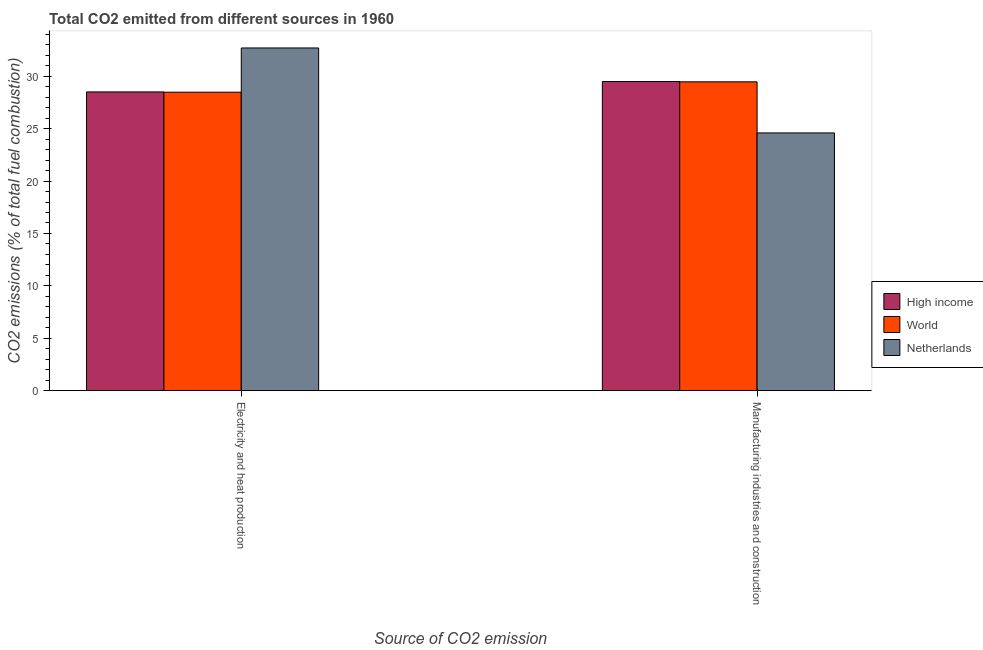How many different coloured bars are there?
Keep it short and to the point. 3. How many bars are there on the 2nd tick from the right?
Make the answer very short. 3. What is the label of the 2nd group of bars from the left?
Your answer should be very brief. Manufacturing industries and construction. What is the co2 emissions due to electricity and heat production in Netherlands?
Provide a succinct answer. 32.7. Across all countries, what is the maximum co2 emissions due to manufacturing industries?
Your answer should be very brief. 29.5. Across all countries, what is the minimum co2 emissions due to manufacturing industries?
Make the answer very short. 24.59. In which country was the co2 emissions due to electricity and heat production minimum?
Provide a succinct answer. World. What is the total co2 emissions due to electricity and heat production in the graph?
Ensure brevity in your answer.  89.69. What is the difference between the co2 emissions due to electricity and heat production in High income and that in Netherlands?
Make the answer very short. -4.19. What is the difference between the co2 emissions due to electricity and heat production in World and the co2 emissions due to manufacturing industries in High income?
Offer a very short reply. -1.02. What is the average co2 emissions due to electricity and heat production per country?
Offer a very short reply. 29.9. What is the difference between the co2 emissions due to electricity and heat production and co2 emissions due to manufacturing industries in Netherlands?
Provide a short and direct response. 8.11. In how many countries, is the co2 emissions due to manufacturing industries greater than 20 %?
Offer a terse response. 3. What is the ratio of the co2 emissions due to electricity and heat production in World to that in Netherlands?
Your answer should be very brief. 0.87. Is the co2 emissions due to manufacturing industries in Netherlands less than that in High income?
Your answer should be very brief. Yes. In how many countries, is the co2 emissions due to electricity and heat production greater than the average co2 emissions due to electricity and heat production taken over all countries?
Your response must be concise. 1. How many bars are there?
Ensure brevity in your answer.  6. How many countries are there in the graph?
Make the answer very short. 3. What is the difference between two consecutive major ticks on the Y-axis?
Your answer should be very brief. 5. Are the values on the major ticks of Y-axis written in scientific E-notation?
Provide a short and direct response. No. Does the graph contain grids?
Give a very brief answer. No. How many legend labels are there?
Make the answer very short. 3. How are the legend labels stacked?
Give a very brief answer. Vertical. What is the title of the graph?
Your response must be concise. Total CO2 emitted from different sources in 1960. What is the label or title of the X-axis?
Make the answer very short. Source of CO2 emission. What is the label or title of the Y-axis?
Your answer should be compact. CO2 emissions (% of total fuel combustion). What is the CO2 emissions (% of total fuel combustion) of High income in Electricity and heat production?
Provide a succinct answer. 28.51. What is the CO2 emissions (% of total fuel combustion) in World in Electricity and heat production?
Your answer should be compact. 28.48. What is the CO2 emissions (% of total fuel combustion) in Netherlands in Electricity and heat production?
Your answer should be very brief. 32.7. What is the CO2 emissions (% of total fuel combustion) of High income in Manufacturing industries and construction?
Provide a succinct answer. 29.5. What is the CO2 emissions (% of total fuel combustion) of World in Manufacturing industries and construction?
Your answer should be compact. 29.47. What is the CO2 emissions (% of total fuel combustion) of Netherlands in Manufacturing industries and construction?
Give a very brief answer. 24.59. Across all Source of CO2 emission, what is the maximum CO2 emissions (% of total fuel combustion) of High income?
Your response must be concise. 29.5. Across all Source of CO2 emission, what is the maximum CO2 emissions (% of total fuel combustion) in World?
Offer a terse response. 29.47. Across all Source of CO2 emission, what is the maximum CO2 emissions (% of total fuel combustion) in Netherlands?
Offer a terse response. 32.7. Across all Source of CO2 emission, what is the minimum CO2 emissions (% of total fuel combustion) in High income?
Make the answer very short. 28.51. Across all Source of CO2 emission, what is the minimum CO2 emissions (% of total fuel combustion) of World?
Your response must be concise. 28.48. Across all Source of CO2 emission, what is the minimum CO2 emissions (% of total fuel combustion) of Netherlands?
Offer a very short reply. 24.59. What is the total CO2 emissions (% of total fuel combustion) in High income in the graph?
Offer a terse response. 58. What is the total CO2 emissions (% of total fuel combustion) of World in the graph?
Your answer should be compact. 57.95. What is the total CO2 emissions (% of total fuel combustion) in Netherlands in the graph?
Make the answer very short. 57.29. What is the difference between the CO2 emissions (% of total fuel combustion) of High income in Electricity and heat production and that in Manufacturing industries and construction?
Your answer should be very brief. -0.99. What is the difference between the CO2 emissions (% of total fuel combustion) in World in Electricity and heat production and that in Manufacturing industries and construction?
Make the answer very short. -0.99. What is the difference between the CO2 emissions (% of total fuel combustion) of Netherlands in Electricity and heat production and that in Manufacturing industries and construction?
Ensure brevity in your answer.  8.11. What is the difference between the CO2 emissions (% of total fuel combustion) in High income in Electricity and heat production and the CO2 emissions (% of total fuel combustion) in World in Manufacturing industries and construction?
Your response must be concise. -0.96. What is the difference between the CO2 emissions (% of total fuel combustion) of High income in Electricity and heat production and the CO2 emissions (% of total fuel combustion) of Netherlands in Manufacturing industries and construction?
Ensure brevity in your answer.  3.91. What is the difference between the CO2 emissions (% of total fuel combustion) of World in Electricity and heat production and the CO2 emissions (% of total fuel combustion) of Netherlands in Manufacturing industries and construction?
Offer a very short reply. 3.89. What is the average CO2 emissions (% of total fuel combustion) in High income per Source of CO2 emission?
Offer a terse response. 29. What is the average CO2 emissions (% of total fuel combustion) in World per Source of CO2 emission?
Keep it short and to the point. 28.97. What is the average CO2 emissions (% of total fuel combustion) of Netherlands per Source of CO2 emission?
Provide a short and direct response. 28.65. What is the difference between the CO2 emissions (% of total fuel combustion) of High income and CO2 emissions (% of total fuel combustion) of World in Electricity and heat production?
Your answer should be very brief. 0.03. What is the difference between the CO2 emissions (% of total fuel combustion) in High income and CO2 emissions (% of total fuel combustion) in Netherlands in Electricity and heat production?
Provide a short and direct response. -4.19. What is the difference between the CO2 emissions (% of total fuel combustion) of World and CO2 emissions (% of total fuel combustion) of Netherlands in Electricity and heat production?
Your answer should be very brief. -4.22. What is the difference between the CO2 emissions (% of total fuel combustion) of High income and CO2 emissions (% of total fuel combustion) of World in Manufacturing industries and construction?
Provide a succinct answer. 0.03. What is the difference between the CO2 emissions (% of total fuel combustion) of High income and CO2 emissions (% of total fuel combustion) of Netherlands in Manufacturing industries and construction?
Offer a very short reply. 4.9. What is the difference between the CO2 emissions (% of total fuel combustion) of World and CO2 emissions (% of total fuel combustion) of Netherlands in Manufacturing industries and construction?
Offer a very short reply. 4.87. What is the ratio of the CO2 emissions (% of total fuel combustion) of High income in Electricity and heat production to that in Manufacturing industries and construction?
Your answer should be compact. 0.97. What is the ratio of the CO2 emissions (% of total fuel combustion) of World in Electricity and heat production to that in Manufacturing industries and construction?
Offer a very short reply. 0.97. What is the ratio of the CO2 emissions (% of total fuel combustion) in Netherlands in Electricity and heat production to that in Manufacturing industries and construction?
Ensure brevity in your answer.  1.33. What is the difference between the highest and the second highest CO2 emissions (% of total fuel combustion) of Netherlands?
Provide a short and direct response. 8.11. What is the difference between the highest and the lowest CO2 emissions (% of total fuel combustion) of High income?
Your response must be concise. 0.99. What is the difference between the highest and the lowest CO2 emissions (% of total fuel combustion) of World?
Provide a succinct answer. 0.99. What is the difference between the highest and the lowest CO2 emissions (% of total fuel combustion) in Netherlands?
Provide a succinct answer. 8.11. 